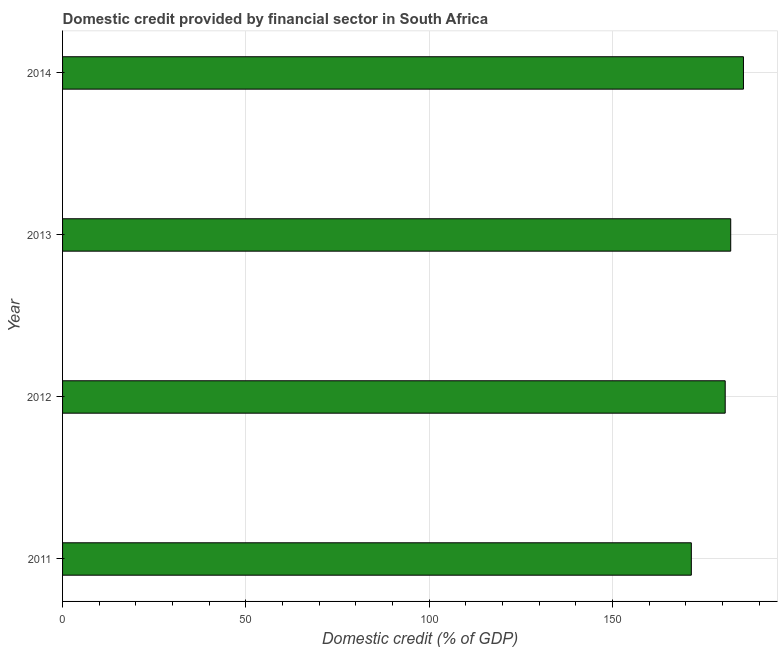What is the title of the graph?
Ensure brevity in your answer.  Domestic credit provided by financial sector in South Africa. What is the label or title of the X-axis?
Provide a short and direct response. Domestic credit (% of GDP). What is the label or title of the Y-axis?
Provide a short and direct response. Year. What is the domestic credit provided by financial sector in 2011?
Provide a short and direct response. 171.46. Across all years, what is the maximum domestic credit provided by financial sector?
Make the answer very short. 185.67. Across all years, what is the minimum domestic credit provided by financial sector?
Give a very brief answer. 171.46. In which year was the domestic credit provided by financial sector maximum?
Make the answer very short. 2014. What is the sum of the domestic credit provided by financial sector?
Provide a succinct answer. 720.04. What is the difference between the domestic credit provided by financial sector in 2012 and 2013?
Your response must be concise. -1.51. What is the average domestic credit provided by financial sector per year?
Make the answer very short. 180.01. What is the median domestic credit provided by financial sector?
Keep it short and to the point. 181.45. What is the ratio of the domestic credit provided by financial sector in 2011 to that in 2012?
Give a very brief answer. 0.95. Is the difference between the domestic credit provided by financial sector in 2012 and 2013 greater than the difference between any two years?
Give a very brief answer. No. What is the difference between the highest and the second highest domestic credit provided by financial sector?
Offer a very short reply. 3.47. What is the difference between the highest and the lowest domestic credit provided by financial sector?
Your answer should be very brief. 14.21. In how many years, is the domestic credit provided by financial sector greater than the average domestic credit provided by financial sector taken over all years?
Provide a succinct answer. 3. How many bars are there?
Your answer should be compact. 4. Are all the bars in the graph horizontal?
Your answer should be very brief. Yes. Are the values on the major ticks of X-axis written in scientific E-notation?
Offer a terse response. No. What is the Domestic credit (% of GDP) of 2011?
Your answer should be very brief. 171.46. What is the Domestic credit (% of GDP) of 2012?
Make the answer very short. 180.7. What is the Domestic credit (% of GDP) of 2013?
Make the answer very short. 182.21. What is the Domestic credit (% of GDP) of 2014?
Keep it short and to the point. 185.67. What is the difference between the Domestic credit (% of GDP) in 2011 and 2012?
Offer a terse response. -9.24. What is the difference between the Domestic credit (% of GDP) in 2011 and 2013?
Give a very brief answer. -10.74. What is the difference between the Domestic credit (% of GDP) in 2011 and 2014?
Make the answer very short. -14.21. What is the difference between the Domestic credit (% of GDP) in 2012 and 2013?
Offer a terse response. -1.51. What is the difference between the Domestic credit (% of GDP) in 2012 and 2014?
Your answer should be very brief. -4.98. What is the difference between the Domestic credit (% of GDP) in 2013 and 2014?
Offer a very short reply. -3.47. What is the ratio of the Domestic credit (% of GDP) in 2011 to that in 2012?
Make the answer very short. 0.95. What is the ratio of the Domestic credit (% of GDP) in 2011 to that in 2013?
Your answer should be compact. 0.94. What is the ratio of the Domestic credit (% of GDP) in 2011 to that in 2014?
Your answer should be compact. 0.92. What is the ratio of the Domestic credit (% of GDP) in 2013 to that in 2014?
Provide a short and direct response. 0.98. 